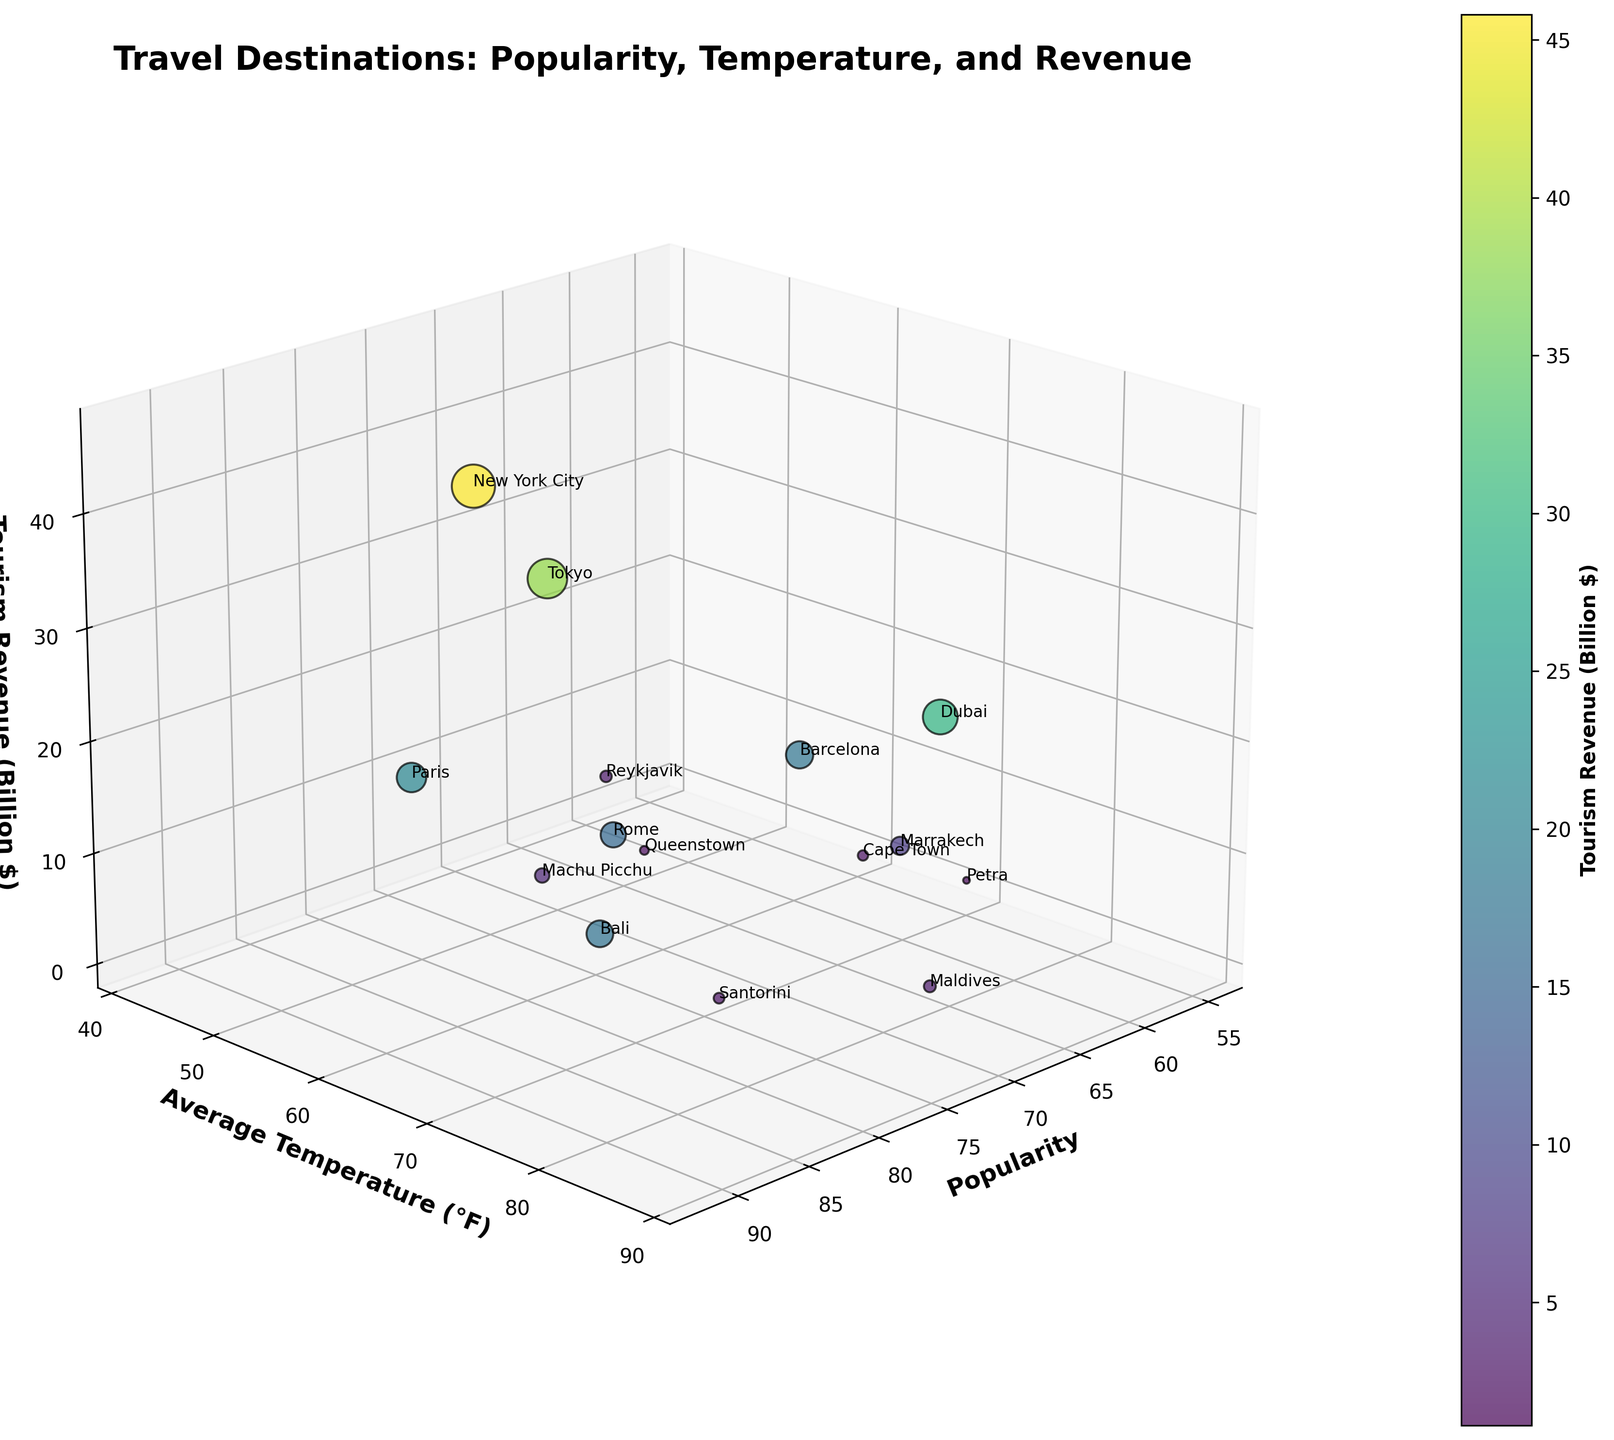Which destination has the highest tourism revenue? Looking at the z-axis, New York City has the highest value for tourism revenue.
Answer: New York City What is the average temperature range for the destinations? The lowest average temperature is in Reykjavik (42°F) and the highest is in Dubai (88°F), so the range is 88 - 42 = 46°F.
Answer: 46°F Which destination has both high popularity and high tourism revenue? Identifying destinations with both high x-axis (popularity) and high z-axis (tourism revenue), New York City fits this criterion with a popularity of 85 and tourism revenue of 45.8 billion dollars.
Answer: New York City Are there any destinations with a lower average temperature but higher tourism revenue than Tokyo? Tokyo has an average temperature of 66°F and tourism revenue of 38.4 billion dollars. New York City has a lower average temperature (62°F) but higher tourism revenue (45.8 billion dollars).
Answer: Yes, New York City Which two cities have a similar average temperature but different tourism revenue? Paris (60°F) and New York City (62°F) have similar temperatures, but their tourism revenues differ significantly, with Paris at 21.3 billion dollars and New York City at 45.8 billion dollars.
Answer: Paris and New York City What is the median tourism revenue for all the destinations? Listing the tourism revenues and finding the median: [1.1, 1.9, 2.6, 2.8, 3.2, 3.5, 5.1, 8.1, 15.6, 17.5, 18.2, 21.3, 29.7, 38.4, 45.8]; the middle value is 8.1 billion dollars.
Answer: 8.1 billion dollars Which destination has the lowest popularity and how does its tourism revenue compare to Reykjavik? Petra has the lowest popularity at 55. Its tourism revenue is 1.1 billion dollars, which is lower than Reykjavik's 3.2 billion dollars.
Answer: Petra has lower tourism revenue than Reykjavik Does a higher average temperature generally equate to higher tourism revenue? Observing the trend, destinations like Dubai (88°F, 29.7 billion dollars) and Maldives (84°F, 3.5 billion dollars) show that higher temperatures do not always correlate with higher tourism revenue.
Answer: No Which destinations fall into the mid-range of popularity (60-80) and how do their tourism revenues vary? Marrakech (62, 8.1), Reykjavik (60, 3.2), Cape Town (58, 2.6), Petra (55, 1.1) all fall within the mid-range popularity with varying revenues from 1.1 to 8.1 billion dollars.
Answer: Marrakech, Reykjavik, Cape Town, Petra with varying revenues 